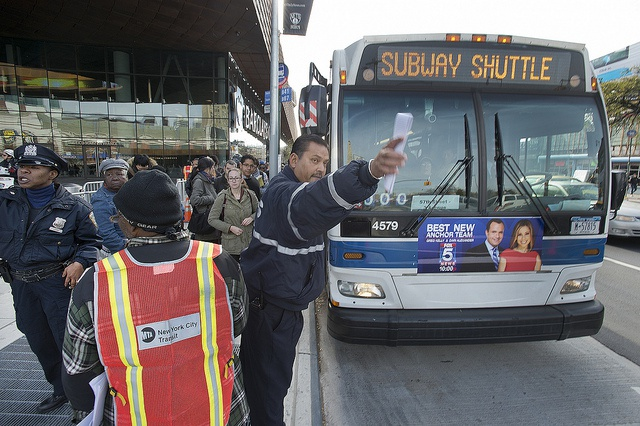Describe the objects in this image and their specific colors. I can see bus in black, gray, and darkgray tones, people in black, brown, khaki, and darkgray tones, people in black, gray, and darkgray tones, people in black, gray, and darkblue tones, and people in black, gray, and darkgray tones in this image. 